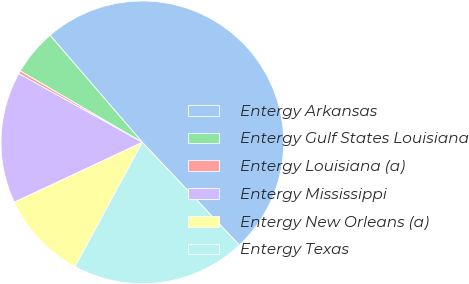Convert chart to OTSL. <chart><loc_0><loc_0><loc_500><loc_500><pie_chart><fcel>Entergy Arkansas<fcel>Entergy Gulf States Louisiana<fcel>Entergy Louisiana (a)<fcel>Entergy Mississippi<fcel>Entergy New Orleans (a)<fcel>Entergy Texas<nl><fcel>49.3%<fcel>5.25%<fcel>0.35%<fcel>15.04%<fcel>10.14%<fcel>19.93%<nl></chart> 